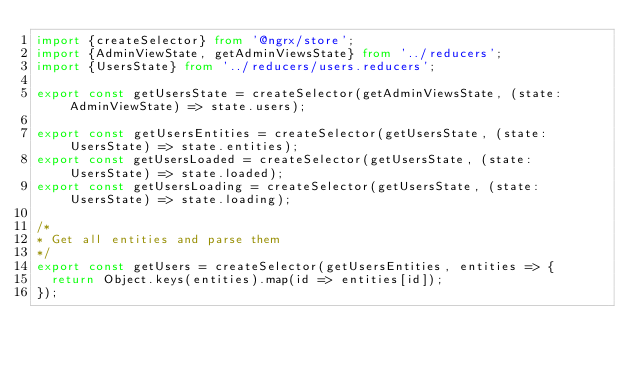Convert code to text. <code><loc_0><loc_0><loc_500><loc_500><_TypeScript_>import {createSelector} from '@ngrx/store';
import {AdminViewState, getAdminViewsState} from '../reducers';
import {UsersState} from '../reducers/users.reducers';

export const getUsersState = createSelector(getAdminViewsState, (state: AdminViewState) => state.users);

export const getUsersEntities = createSelector(getUsersState, (state: UsersState) => state.entities);
export const getUsersLoaded = createSelector(getUsersState, (state: UsersState) => state.loaded);
export const getUsersLoading = createSelector(getUsersState, (state: UsersState) => state.loading);

/*
* Get all entities and parse them
*/
export const getUsers = createSelector(getUsersEntities, entities => {
  return Object.keys(entities).map(id => entities[id]);
});
</code> 